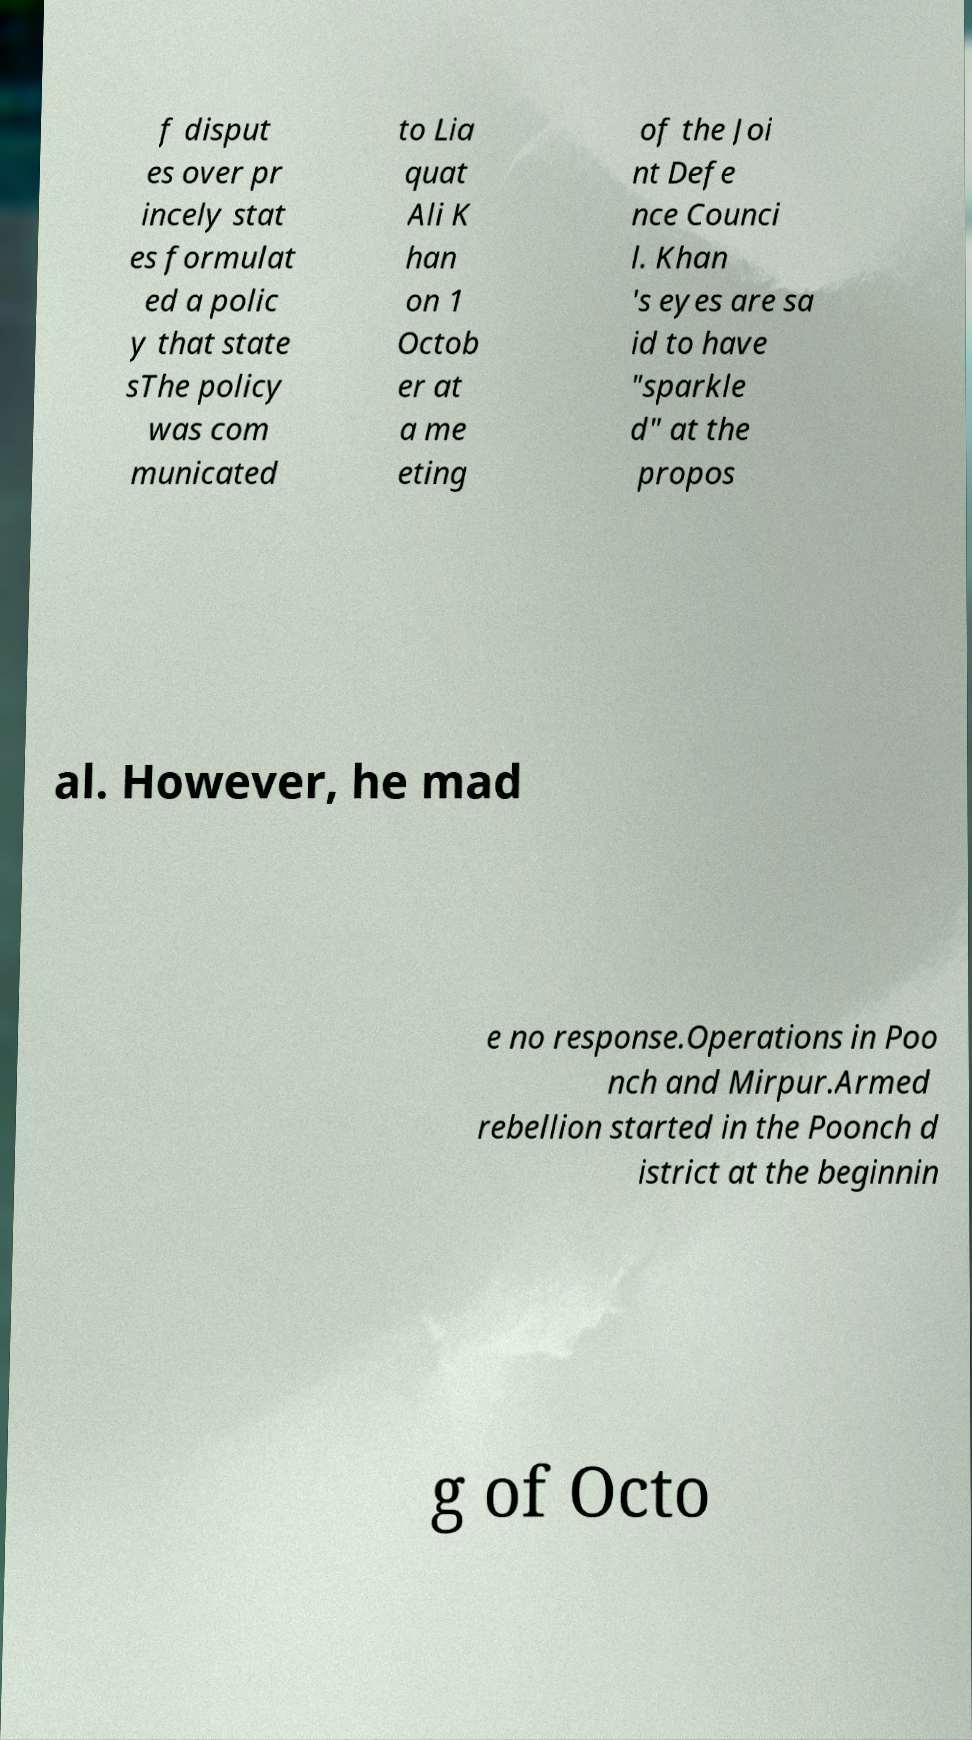For documentation purposes, I need the text within this image transcribed. Could you provide that? f disput es over pr incely stat es formulat ed a polic y that state sThe policy was com municated to Lia quat Ali K han on 1 Octob er at a me eting of the Joi nt Defe nce Counci l. Khan 's eyes are sa id to have "sparkle d" at the propos al. However, he mad e no response.Operations in Poo nch and Mirpur.Armed rebellion started in the Poonch d istrict at the beginnin g of Octo 